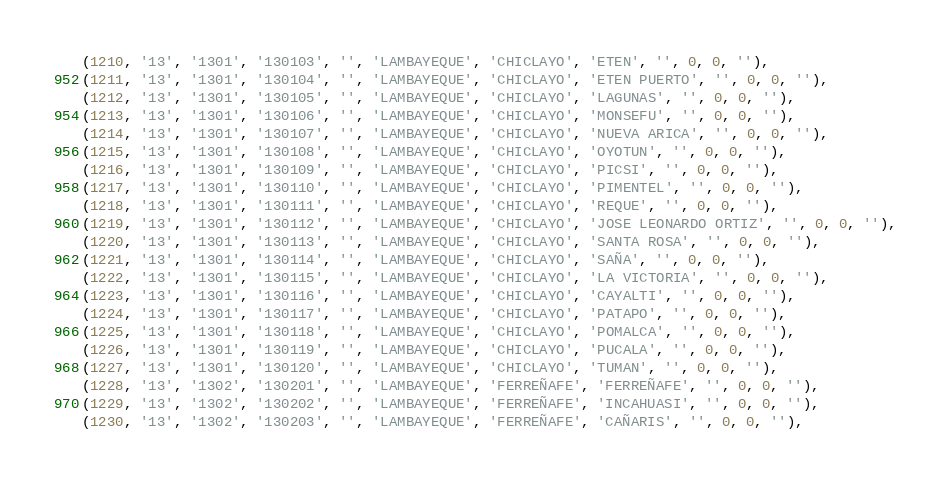<code> <loc_0><loc_0><loc_500><loc_500><_SQL_>(1210, '13', '1301', '130103', '', 'LAMBAYEQUE', 'CHICLAYO', 'ETEN', '', 0, 0, ''),
(1211, '13', '1301', '130104', '', 'LAMBAYEQUE', 'CHICLAYO', 'ETEN PUERTO', '', 0, 0, ''),
(1212, '13', '1301', '130105', '', 'LAMBAYEQUE', 'CHICLAYO', 'LAGUNAS', '', 0, 0, ''),
(1213, '13', '1301', '130106', '', 'LAMBAYEQUE', 'CHICLAYO', 'MONSEFU', '', 0, 0, ''),
(1214, '13', '1301', '130107', '', 'LAMBAYEQUE', 'CHICLAYO', 'NUEVA ARICA', '', 0, 0, ''),
(1215, '13', '1301', '130108', '', 'LAMBAYEQUE', 'CHICLAYO', 'OYOTUN', '', 0, 0, ''),
(1216, '13', '1301', '130109', '', 'LAMBAYEQUE', 'CHICLAYO', 'PICSI', '', 0, 0, ''),
(1217, '13', '1301', '130110', '', 'LAMBAYEQUE', 'CHICLAYO', 'PIMENTEL', '', 0, 0, ''),
(1218, '13', '1301', '130111', '', 'LAMBAYEQUE', 'CHICLAYO', 'REQUE', '', 0, 0, ''),
(1219, '13', '1301', '130112', '', 'LAMBAYEQUE', 'CHICLAYO', 'JOSE LEONARDO ORTIZ', '', 0, 0, ''),
(1220, '13', '1301', '130113', '', 'LAMBAYEQUE', 'CHICLAYO', 'SANTA ROSA', '', 0, 0, ''),
(1221, '13', '1301', '130114', '', 'LAMBAYEQUE', 'CHICLAYO', 'SAÑA', '', 0, 0, ''),
(1222, '13', '1301', '130115', '', 'LAMBAYEQUE', 'CHICLAYO', 'LA VICTORIA', '', 0, 0, ''),
(1223, '13', '1301', '130116', '', 'LAMBAYEQUE', 'CHICLAYO', 'CAYALTI', '', 0, 0, ''),
(1224, '13', '1301', '130117', '', 'LAMBAYEQUE', 'CHICLAYO', 'PATAPO', '', 0, 0, ''),
(1225, '13', '1301', '130118', '', 'LAMBAYEQUE', 'CHICLAYO', 'POMALCA', '', 0, 0, ''),
(1226, '13', '1301', '130119', '', 'LAMBAYEQUE', 'CHICLAYO', 'PUCALA', '', 0, 0, ''),
(1227, '13', '1301', '130120', '', 'LAMBAYEQUE', 'CHICLAYO', 'TUMAN', '', 0, 0, ''),
(1228, '13', '1302', '130201', '', 'LAMBAYEQUE', 'FERREÑAFE', 'FERREÑAFE', '', 0, 0, ''),
(1229, '13', '1302', '130202', '', 'LAMBAYEQUE', 'FERREÑAFE', 'INCAHUASI', '', 0, 0, ''),
(1230, '13', '1302', '130203', '', 'LAMBAYEQUE', 'FERREÑAFE', 'CAÑARIS', '', 0, 0, ''),</code> 